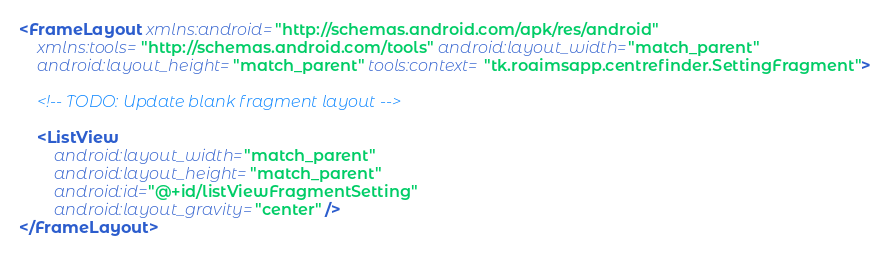Convert code to text. <code><loc_0><loc_0><loc_500><loc_500><_XML_><FrameLayout xmlns:android="http://schemas.android.com/apk/res/android"
    xmlns:tools="http://schemas.android.com/tools" android:layout_width="match_parent"
    android:layout_height="match_parent" tools:context="tk.roaimsapp.centrefinder.SettingFragment">

    <!-- TODO: Update blank fragment layout -->

    <ListView
        android:layout_width="match_parent"
        android:layout_height="match_parent"
        android:id="@+id/listViewFragmentSetting"
        android:layout_gravity="center" />
</FrameLayout>
</code> 